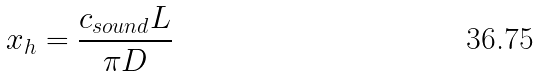<formula> <loc_0><loc_0><loc_500><loc_500>x _ { h } = \frac { c _ { s o u n d } { L } } { { \pi } D }</formula> 